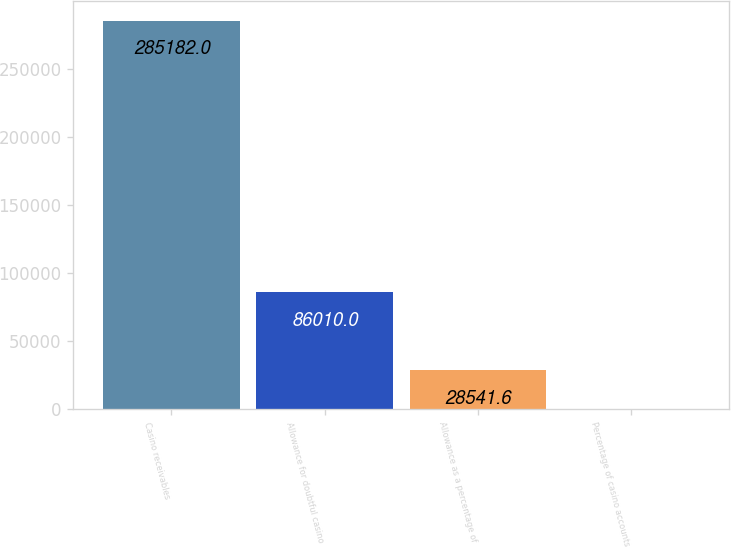<chart> <loc_0><loc_0><loc_500><loc_500><bar_chart><fcel>Casino receivables<fcel>Allowance for doubtful casino<fcel>Allowance as a percentage of<fcel>Percentage of casino accounts<nl><fcel>285182<fcel>86010<fcel>28541.6<fcel>26<nl></chart> 